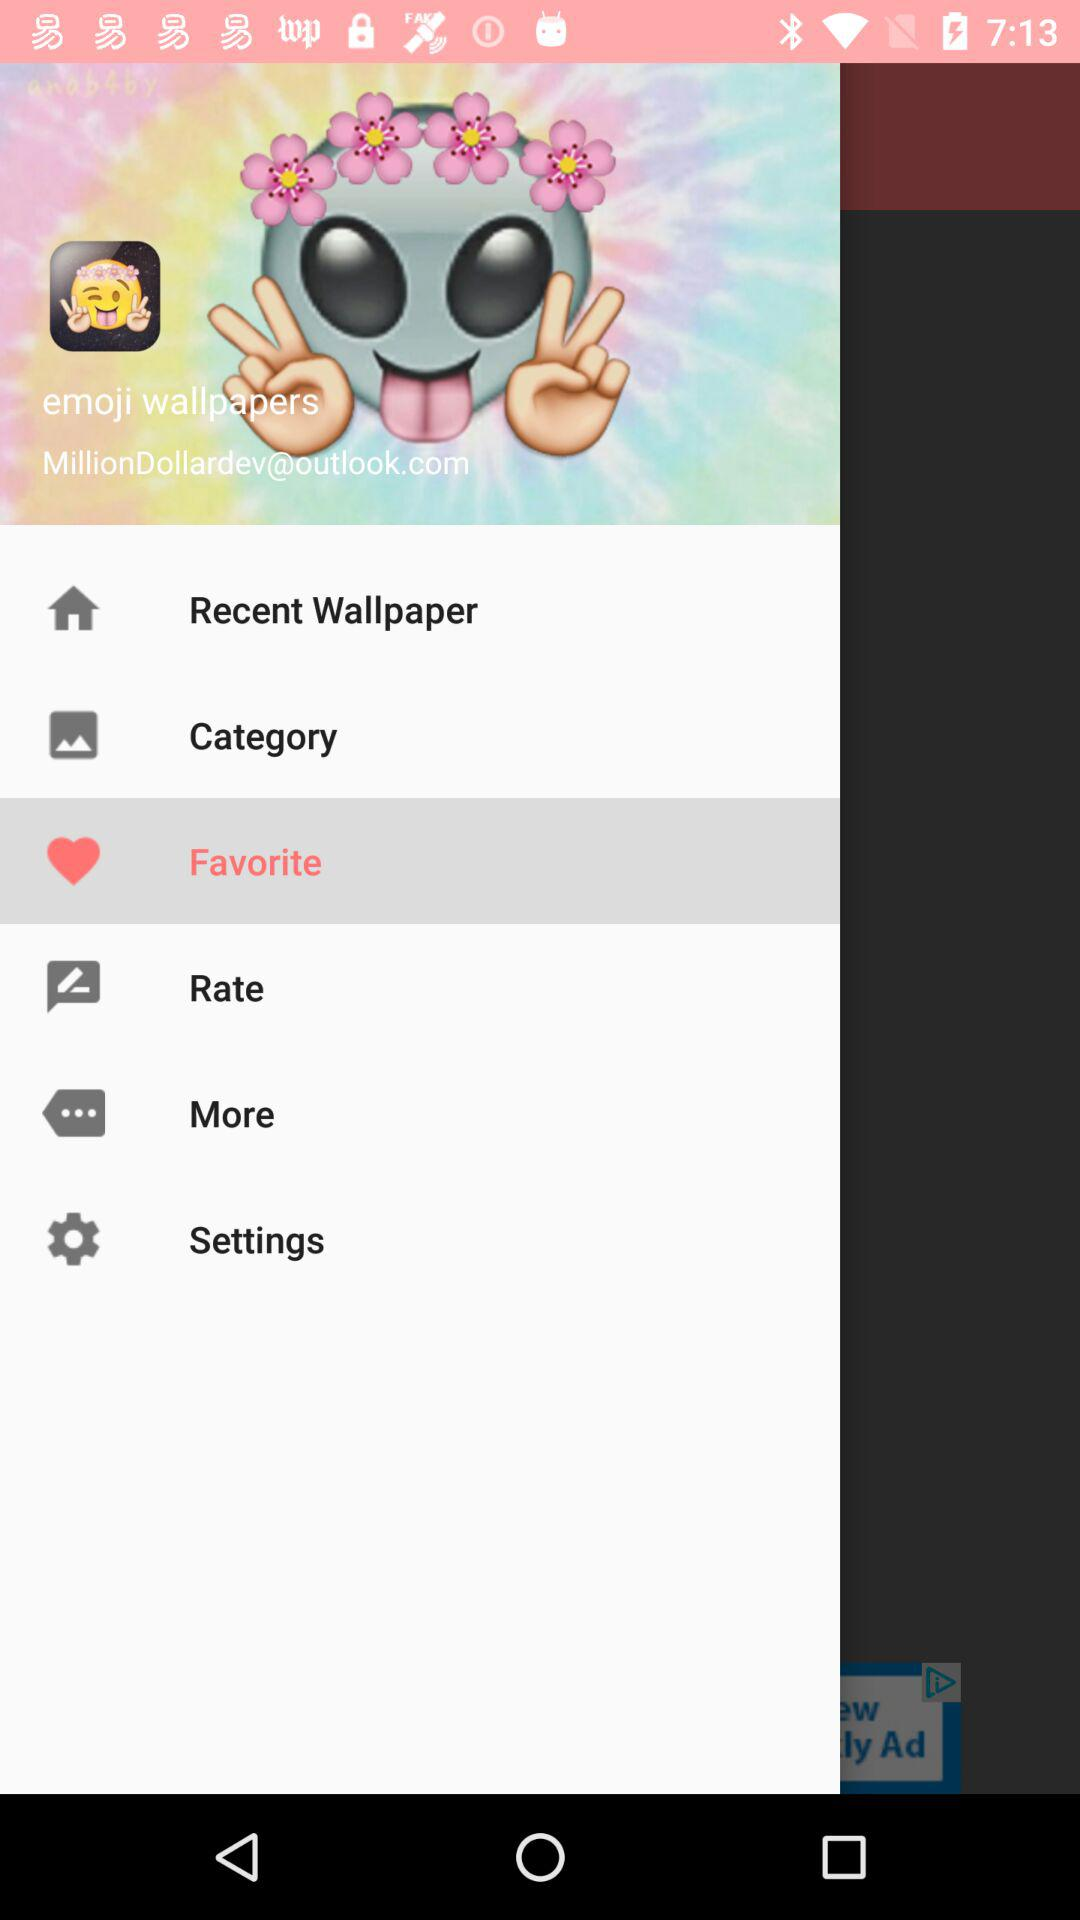Which item has been selected? The selected item is "Favorite". 